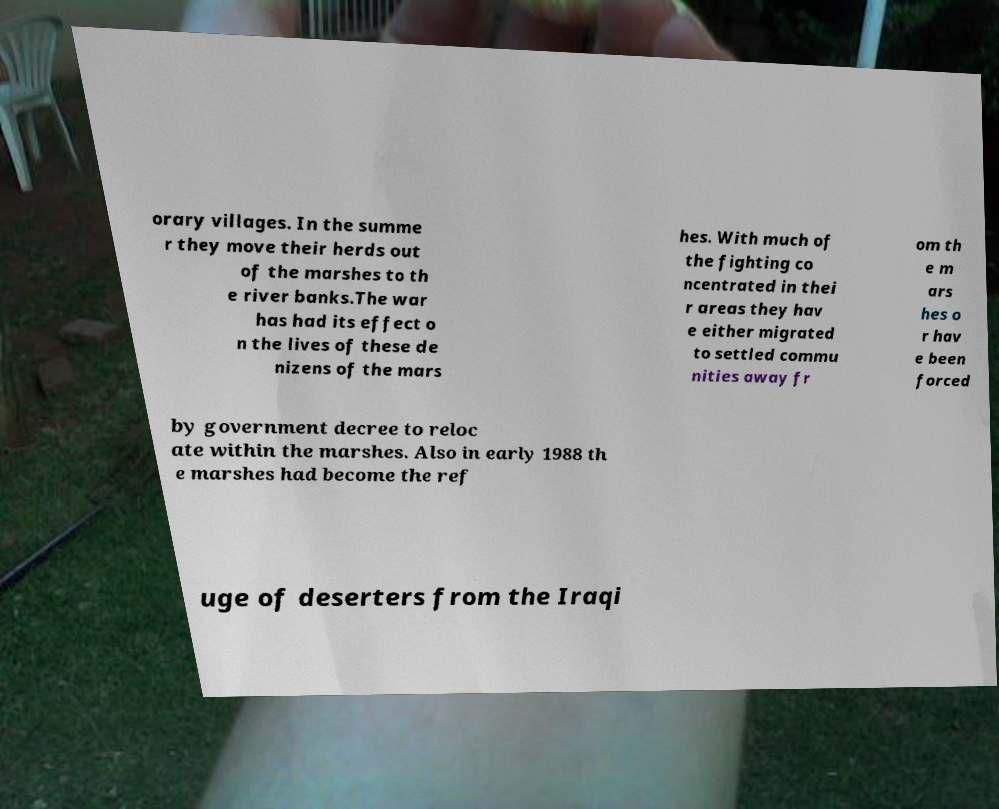There's text embedded in this image that I need extracted. Can you transcribe it verbatim? orary villages. In the summe r they move their herds out of the marshes to th e river banks.The war has had its effect o n the lives of these de nizens of the mars hes. With much of the fighting co ncentrated in thei r areas they hav e either migrated to settled commu nities away fr om th e m ars hes o r hav e been forced by government decree to reloc ate within the marshes. Also in early 1988 th e marshes had become the ref uge of deserters from the Iraqi 